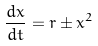Convert formula to latex. <formula><loc_0><loc_0><loc_500><loc_500>\frac { d x } { d t } = r \pm x ^ { 2 }</formula> 